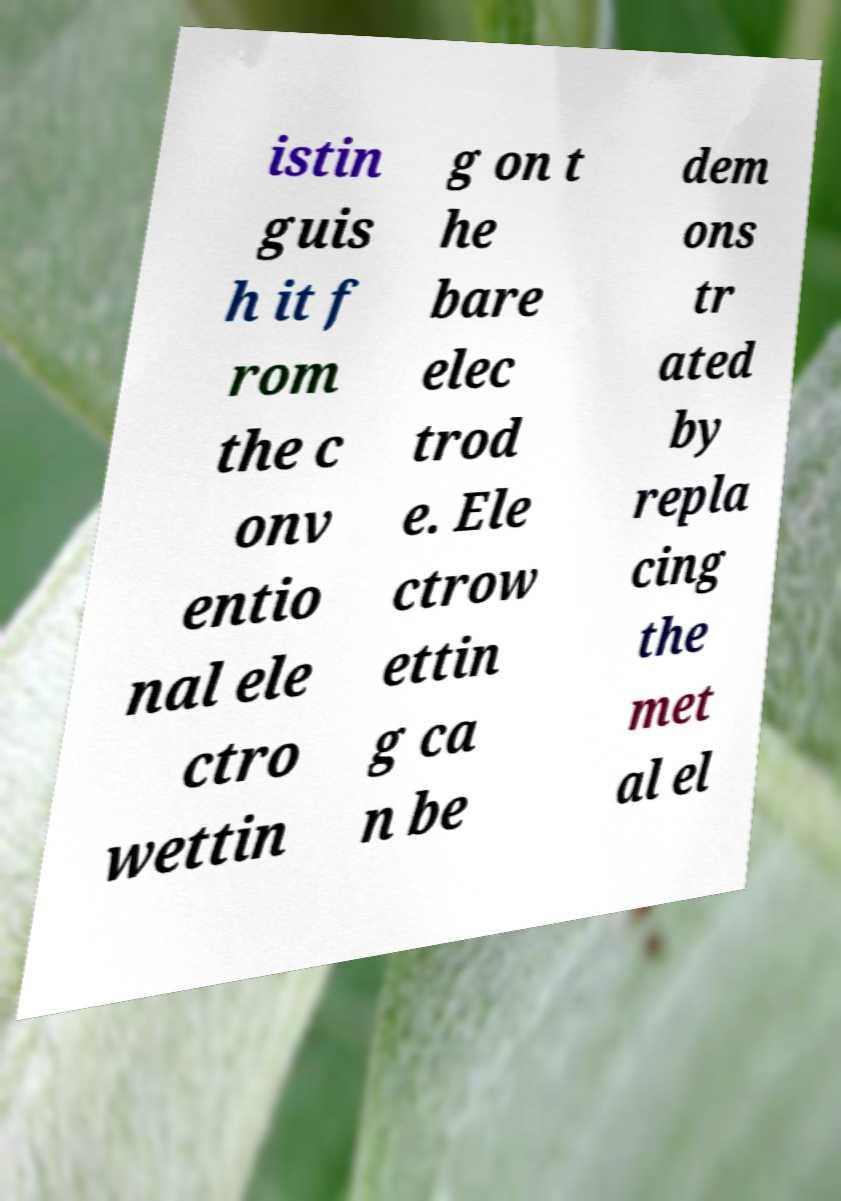Could you assist in decoding the text presented in this image and type it out clearly? istin guis h it f rom the c onv entio nal ele ctro wettin g on t he bare elec trod e. Ele ctrow ettin g ca n be dem ons tr ated by repla cing the met al el 